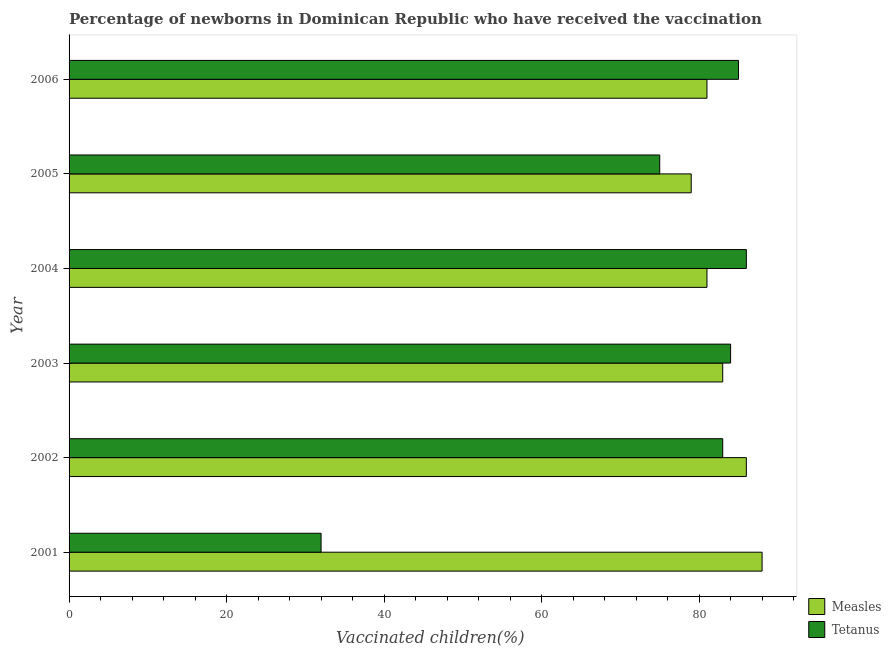Are the number of bars per tick equal to the number of legend labels?
Give a very brief answer. Yes. How many bars are there on the 3rd tick from the bottom?
Ensure brevity in your answer.  2. What is the label of the 6th group of bars from the top?
Your answer should be very brief. 2001. In how many cases, is the number of bars for a given year not equal to the number of legend labels?
Offer a terse response. 0. What is the percentage of newborns who received vaccination for tetanus in 2006?
Your answer should be compact. 85. Across all years, what is the maximum percentage of newborns who received vaccination for measles?
Offer a terse response. 88. Across all years, what is the minimum percentage of newborns who received vaccination for tetanus?
Make the answer very short. 32. In which year was the percentage of newborns who received vaccination for measles maximum?
Offer a very short reply. 2001. What is the total percentage of newborns who received vaccination for tetanus in the graph?
Provide a succinct answer. 445. What is the difference between the percentage of newborns who received vaccination for tetanus in 2001 and that in 2004?
Your answer should be compact. -54. What is the difference between the percentage of newborns who received vaccination for tetanus in 2001 and the percentage of newborns who received vaccination for measles in 2005?
Make the answer very short. -47. What is the average percentage of newborns who received vaccination for tetanus per year?
Make the answer very short. 74.17. In the year 2002, what is the difference between the percentage of newborns who received vaccination for tetanus and percentage of newborns who received vaccination for measles?
Offer a very short reply. -3. What is the ratio of the percentage of newborns who received vaccination for tetanus in 2003 to that in 2005?
Your response must be concise. 1.12. What is the difference between the highest and the second highest percentage of newborns who received vaccination for tetanus?
Provide a short and direct response. 1. What is the difference between the highest and the lowest percentage of newborns who received vaccination for tetanus?
Your answer should be very brief. 54. In how many years, is the percentage of newborns who received vaccination for tetanus greater than the average percentage of newborns who received vaccination for tetanus taken over all years?
Your response must be concise. 5. What does the 2nd bar from the top in 2005 represents?
Provide a short and direct response. Measles. What does the 2nd bar from the bottom in 2001 represents?
Give a very brief answer. Tetanus. How many years are there in the graph?
Provide a succinct answer. 6. Are the values on the major ticks of X-axis written in scientific E-notation?
Your answer should be compact. No. Does the graph contain any zero values?
Your response must be concise. No. Does the graph contain grids?
Your response must be concise. No. How many legend labels are there?
Provide a short and direct response. 2. How are the legend labels stacked?
Your answer should be very brief. Vertical. What is the title of the graph?
Your answer should be compact. Percentage of newborns in Dominican Republic who have received the vaccination. What is the label or title of the X-axis?
Your answer should be very brief. Vaccinated children(%)
. What is the Vaccinated children(%)
 in Measles in 2001?
Give a very brief answer. 88. What is the Vaccinated children(%)
 in Measles in 2003?
Offer a terse response. 83. What is the Vaccinated children(%)
 in Tetanus in 2004?
Your answer should be compact. 86. What is the Vaccinated children(%)
 in Measles in 2005?
Your answer should be very brief. 79. What is the Vaccinated children(%)
 in Tetanus in 2005?
Your answer should be compact. 75. Across all years, what is the maximum Vaccinated children(%)
 in Measles?
Provide a succinct answer. 88. Across all years, what is the maximum Vaccinated children(%)
 in Tetanus?
Give a very brief answer. 86. Across all years, what is the minimum Vaccinated children(%)
 of Measles?
Make the answer very short. 79. Across all years, what is the minimum Vaccinated children(%)
 of Tetanus?
Provide a succinct answer. 32. What is the total Vaccinated children(%)
 in Measles in the graph?
Ensure brevity in your answer.  498. What is the total Vaccinated children(%)
 in Tetanus in the graph?
Provide a short and direct response. 445. What is the difference between the Vaccinated children(%)
 in Measles in 2001 and that in 2002?
Ensure brevity in your answer.  2. What is the difference between the Vaccinated children(%)
 in Tetanus in 2001 and that in 2002?
Make the answer very short. -51. What is the difference between the Vaccinated children(%)
 in Measles in 2001 and that in 2003?
Ensure brevity in your answer.  5. What is the difference between the Vaccinated children(%)
 of Tetanus in 2001 and that in 2003?
Offer a very short reply. -52. What is the difference between the Vaccinated children(%)
 of Tetanus in 2001 and that in 2004?
Provide a succinct answer. -54. What is the difference between the Vaccinated children(%)
 of Tetanus in 2001 and that in 2005?
Provide a short and direct response. -43. What is the difference between the Vaccinated children(%)
 of Tetanus in 2001 and that in 2006?
Your answer should be very brief. -53. What is the difference between the Vaccinated children(%)
 of Measles in 2002 and that in 2004?
Give a very brief answer. 5. What is the difference between the Vaccinated children(%)
 of Tetanus in 2002 and that in 2004?
Give a very brief answer. -3. What is the difference between the Vaccinated children(%)
 in Measles in 2002 and that in 2005?
Your response must be concise. 7. What is the difference between the Vaccinated children(%)
 of Tetanus in 2002 and that in 2005?
Make the answer very short. 8. What is the difference between the Vaccinated children(%)
 of Measles in 2002 and that in 2006?
Ensure brevity in your answer.  5. What is the difference between the Vaccinated children(%)
 in Measles in 2003 and that in 2004?
Your answer should be compact. 2. What is the difference between the Vaccinated children(%)
 of Measles in 2003 and that in 2005?
Provide a short and direct response. 4. What is the difference between the Vaccinated children(%)
 in Measles in 2003 and that in 2006?
Your response must be concise. 2. What is the difference between the Vaccinated children(%)
 in Measles in 2001 and the Vaccinated children(%)
 in Tetanus in 2002?
Give a very brief answer. 5. What is the difference between the Vaccinated children(%)
 of Measles in 2002 and the Vaccinated children(%)
 of Tetanus in 2004?
Make the answer very short. 0. What is the difference between the Vaccinated children(%)
 in Measles in 2002 and the Vaccinated children(%)
 in Tetanus in 2006?
Ensure brevity in your answer.  1. What is the difference between the Vaccinated children(%)
 of Measles in 2003 and the Vaccinated children(%)
 of Tetanus in 2005?
Make the answer very short. 8. What is the difference between the Vaccinated children(%)
 in Measles in 2003 and the Vaccinated children(%)
 in Tetanus in 2006?
Your response must be concise. -2. What is the difference between the Vaccinated children(%)
 of Measles in 2005 and the Vaccinated children(%)
 of Tetanus in 2006?
Your answer should be compact. -6. What is the average Vaccinated children(%)
 of Tetanus per year?
Your response must be concise. 74.17. In the year 2001, what is the difference between the Vaccinated children(%)
 of Measles and Vaccinated children(%)
 of Tetanus?
Your answer should be compact. 56. In the year 2003, what is the difference between the Vaccinated children(%)
 of Measles and Vaccinated children(%)
 of Tetanus?
Ensure brevity in your answer.  -1. What is the ratio of the Vaccinated children(%)
 in Measles in 2001 to that in 2002?
Provide a short and direct response. 1.02. What is the ratio of the Vaccinated children(%)
 in Tetanus in 2001 to that in 2002?
Provide a short and direct response. 0.39. What is the ratio of the Vaccinated children(%)
 of Measles in 2001 to that in 2003?
Provide a short and direct response. 1.06. What is the ratio of the Vaccinated children(%)
 in Tetanus in 2001 to that in 2003?
Ensure brevity in your answer.  0.38. What is the ratio of the Vaccinated children(%)
 of Measles in 2001 to that in 2004?
Provide a short and direct response. 1.09. What is the ratio of the Vaccinated children(%)
 in Tetanus in 2001 to that in 2004?
Make the answer very short. 0.37. What is the ratio of the Vaccinated children(%)
 in Measles in 2001 to that in 2005?
Keep it short and to the point. 1.11. What is the ratio of the Vaccinated children(%)
 of Tetanus in 2001 to that in 2005?
Your answer should be compact. 0.43. What is the ratio of the Vaccinated children(%)
 of Measles in 2001 to that in 2006?
Make the answer very short. 1.09. What is the ratio of the Vaccinated children(%)
 in Tetanus in 2001 to that in 2006?
Make the answer very short. 0.38. What is the ratio of the Vaccinated children(%)
 in Measles in 2002 to that in 2003?
Your response must be concise. 1.04. What is the ratio of the Vaccinated children(%)
 in Measles in 2002 to that in 2004?
Ensure brevity in your answer.  1.06. What is the ratio of the Vaccinated children(%)
 of Tetanus in 2002 to that in 2004?
Your response must be concise. 0.97. What is the ratio of the Vaccinated children(%)
 of Measles in 2002 to that in 2005?
Your answer should be very brief. 1.09. What is the ratio of the Vaccinated children(%)
 of Tetanus in 2002 to that in 2005?
Offer a very short reply. 1.11. What is the ratio of the Vaccinated children(%)
 in Measles in 2002 to that in 2006?
Give a very brief answer. 1.06. What is the ratio of the Vaccinated children(%)
 in Tetanus in 2002 to that in 2006?
Keep it short and to the point. 0.98. What is the ratio of the Vaccinated children(%)
 of Measles in 2003 to that in 2004?
Offer a very short reply. 1.02. What is the ratio of the Vaccinated children(%)
 of Tetanus in 2003 to that in 2004?
Offer a terse response. 0.98. What is the ratio of the Vaccinated children(%)
 in Measles in 2003 to that in 2005?
Ensure brevity in your answer.  1.05. What is the ratio of the Vaccinated children(%)
 in Tetanus in 2003 to that in 2005?
Make the answer very short. 1.12. What is the ratio of the Vaccinated children(%)
 of Measles in 2003 to that in 2006?
Offer a terse response. 1.02. What is the ratio of the Vaccinated children(%)
 in Tetanus in 2003 to that in 2006?
Provide a short and direct response. 0.99. What is the ratio of the Vaccinated children(%)
 of Measles in 2004 to that in 2005?
Provide a short and direct response. 1.03. What is the ratio of the Vaccinated children(%)
 of Tetanus in 2004 to that in 2005?
Keep it short and to the point. 1.15. What is the ratio of the Vaccinated children(%)
 in Tetanus in 2004 to that in 2006?
Provide a short and direct response. 1.01. What is the ratio of the Vaccinated children(%)
 of Measles in 2005 to that in 2006?
Make the answer very short. 0.98. What is the ratio of the Vaccinated children(%)
 in Tetanus in 2005 to that in 2006?
Your answer should be compact. 0.88. What is the difference between the highest and the second highest Vaccinated children(%)
 of Measles?
Keep it short and to the point. 2. What is the difference between the highest and the second highest Vaccinated children(%)
 in Tetanus?
Offer a very short reply. 1. What is the difference between the highest and the lowest Vaccinated children(%)
 of Measles?
Offer a very short reply. 9. What is the difference between the highest and the lowest Vaccinated children(%)
 of Tetanus?
Offer a very short reply. 54. 